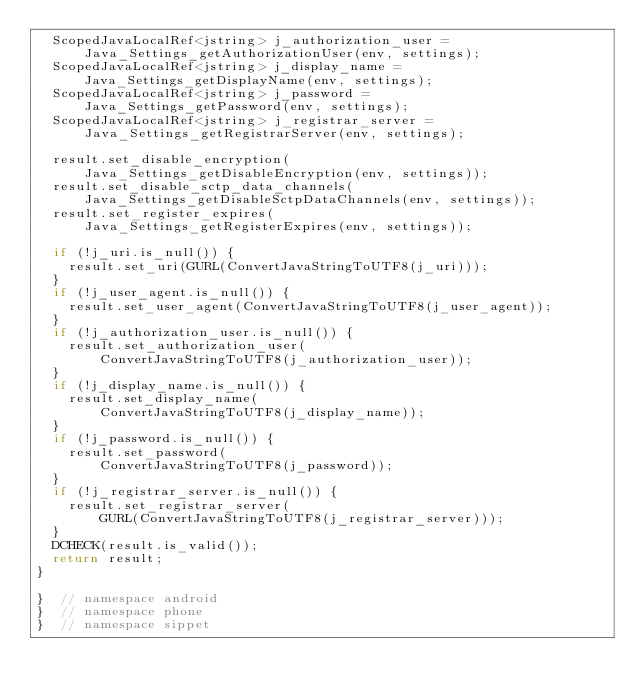<code> <loc_0><loc_0><loc_500><loc_500><_C++_>  ScopedJavaLocalRef<jstring> j_authorization_user =
      Java_Settings_getAuthorizationUser(env, settings);
  ScopedJavaLocalRef<jstring> j_display_name =
      Java_Settings_getDisplayName(env, settings);
  ScopedJavaLocalRef<jstring> j_password =
      Java_Settings_getPassword(env, settings);
  ScopedJavaLocalRef<jstring> j_registrar_server =
      Java_Settings_getRegistrarServer(env, settings);

  result.set_disable_encryption(
      Java_Settings_getDisableEncryption(env, settings));
  result.set_disable_sctp_data_channels(
      Java_Settings_getDisableSctpDataChannels(env, settings));
  result.set_register_expires(
      Java_Settings_getRegisterExpires(env, settings));

  if (!j_uri.is_null()) {
    result.set_uri(GURL(ConvertJavaStringToUTF8(j_uri)));
  }
  if (!j_user_agent.is_null()) {
    result.set_user_agent(ConvertJavaStringToUTF8(j_user_agent));
  }
  if (!j_authorization_user.is_null()) {
    result.set_authorization_user(
        ConvertJavaStringToUTF8(j_authorization_user));
  }
  if (!j_display_name.is_null()) {
    result.set_display_name(
        ConvertJavaStringToUTF8(j_display_name));
  }
  if (!j_password.is_null()) {
    result.set_password(
        ConvertJavaStringToUTF8(j_password));
  }
  if (!j_registrar_server.is_null()) {
    result.set_registrar_server(
        GURL(ConvertJavaStringToUTF8(j_registrar_server)));
  }
  DCHECK(result.is_valid());
  return result;
}

}  // namespace android
}  // namespace phone
}  // namespace sippet
</code> 